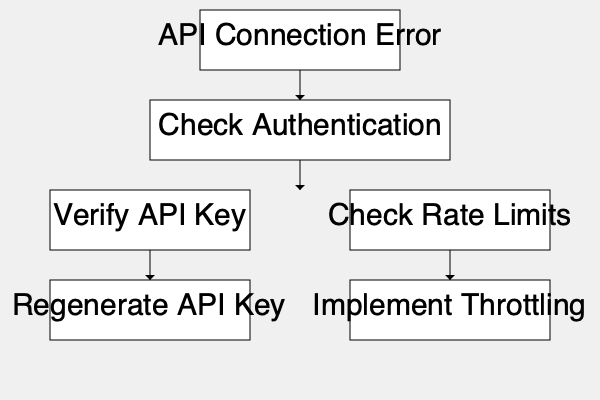According to the flowchart, what is the first step in troubleshooting an API connection error? 1. The flowchart begins with the "API Connection Error" box at the top.
2. From there, an arrow points down to the next step.
3. The box immediately below "API Connection Error" is labeled "Check Authentication".
4. This indicates that checking authentication is the first step in the troubleshooting process.
5. After checking authentication, the flowchart branches into two possible paths: "Verify API Key" and "Check Rate Limits".
6. These subsequent steps would only be taken after the initial authentication check.
Answer: Check Authentication 